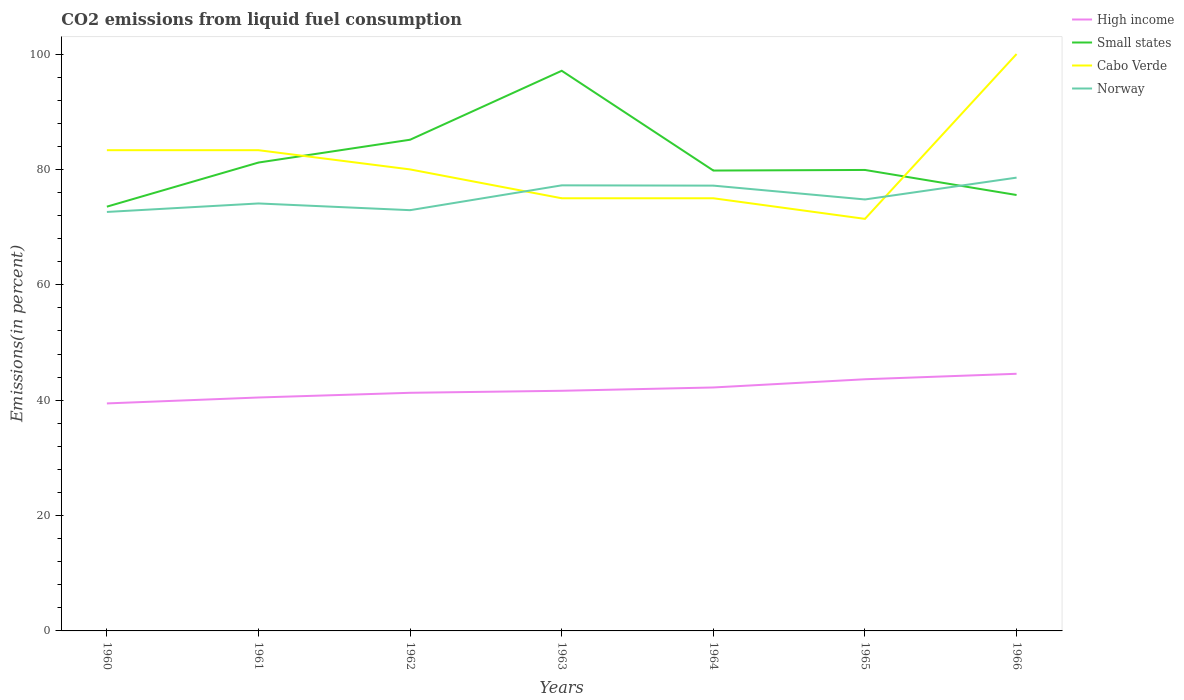How many different coloured lines are there?
Provide a short and direct response. 4. Does the line corresponding to Norway intersect with the line corresponding to Cabo Verde?
Give a very brief answer. Yes. Is the number of lines equal to the number of legend labels?
Provide a short and direct response. Yes. Across all years, what is the maximum total CO2 emitted in Small states?
Keep it short and to the point. 73.54. In which year was the total CO2 emitted in High income maximum?
Your answer should be compact. 1960. What is the total total CO2 emitted in Cabo Verde in the graph?
Make the answer very short. 8.33. What is the difference between the highest and the second highest total CO2 emitted in Cabo Verde?
Give a very brief answer. 28.57. Is the total CO2 emitted in High income strictly greater than the total CO2 emitted in Small states over the years?
Your response must be concise. Yes. How many years are there in the graph?
Keep it short and to the point. 7. What is the difference between two consecutive major ticks on the Y-axis?
Your response must be concise. 20. Does the graph contain any zero values?
Provide a short and direct response. No. Where does the legend appear in the graph?
Offer a terse response. Top right. How many legend labels are there?
Ensure brevity in your answer.  4. What is the title of the graph?
Offer a very short reply. CO2 emissions from liquid fuel consumption. Does "Honduras" appear as one of the legend labels in the graph?
Your response must be concise. No. What is the label or title of the X-axis?
Offer a terse response. Years. What is the label or title of the Y-axis?
Offer a very short reply. Emissions(in percent). What is the Emissions(in percent) of High income in 1960?
Your answer should be compact. 39.44. What is the Emissions(in percent) in Small states in 1960?
Give a very brief answer. 73.54. What is the Emissions(in percent) in Cabo Verde in 1960?
Give a very brief answer. 83.33. What is the Emissions(in percent) in Norway in 1960?
Your answer should be very brief. 72.63. What is the Emissions(in percent) of High income in 1961?
Provide a succinct answer. 40.46. What is the Emissions(in percent) in Small states in 1961?
Ensure brevity in your answer.  81.19. What is the Emissions(in percent) of Cabo Verde in 1961?
Provide a short and direct response. 83.33. What is the Emissions(in percent) in Norway in 1961?
Your answer should be compact. 74.1. What is the Emissions(in percent) of High income in 1962?
Offer a terse response. 41.28. What is the Emissions(in percent) of Small states in 1962?
Keep it short and to the point. 85.15. What is the Emissions(in percent) in Norway in 1962?
Provide a short and direct response. 72.94. What is the Emissions(in percent) of High income in 1963?
Ensure brevity in your answer.  41.63. What is the Emissions(in percent) in Small states in 1963?
Provide a succinct answer. 97.1. What is the Emissions(in percent) in Cabo Verde in 1963?
Your answer should be compact. 75. What is the Emissions(in percent) of Norway in 1963?
Your answer should be compact. 77.24. What is the Emissions(in percent) of High income in 1964?
Offer a very short reply. 42.2. What is the Emissions(in percent) in Small states in 1964?
Your response must be concise. 79.81. What is the Emissions(in percent) in Norway in 1964?
Ensure brevity in your answer.  77.19. What is the Emissions(in percent) in High income in 1965?
Provide a short and direct response. 43.63. What is the Emissions(in percent) of Small states in 1965?
Ensure brevity in your answer.  79.91. What is the Emissions(in percent) in Cabo Verde in 1965?
Ensure brevity in your answer.  71.43. What is the Emissions(in percent) in Norway in 1965?
Give a very brief answer. 74.79. What is the Emissions(in percent) in High income in 1966?
Your answer should be very brief. 44.57. What is the Emissions(in percent) of Small states in 1966?
Give a very brief answer. 75.56. What is the Emissions(in percent) of Cabo Verde in 1966?
Your response must be concise. 100. What is the Emissions(in percent) in Norway in 1966?
Ensure brevity in your answer.  78.58. Across all years, what is the maximum Emissions(in percent) of High income?
Make the answer very short. 44.57. Across all years, what is the maximum Emissions(in percent) in Small states?
Offer a terse response. 97.1. Across all years, what is the maximum Emissions(in percent) in Cabo Verde?
Keep it short and to the point. 100. Across all years, what is the maximum Emissions(in percent) in Norway?
Keep it short and to the point. 78.58. Across all years, what is the minimum Emissions(in percent) in High income?
Provide a short and direct response. 39.44. Across all years, what is the minimum Emissions(in percent) in Small states?
Offer a terse response. 73.54. Across all years, what is the minimum Emissions(in percent) of Cabo Verde?
Keep it short and to the point. 71.43. Across all years, what is the minimum Emissions(in percent) in Norway?
Provide a succinct answer. 72.63. What is the total Emissions(in percent) in High income in the graph?
Make the answer very short. 293.21. What is the total Emissions(in percent) of Small states in the graph?
Offer a terse response. 572.26. What is the total Emissions(in percent) of Cabo Verde in the graph?
Give a very brief answer. 568.1. What is the total Emissions(in percent) of Norway in the graph?
Ensure brevity in your answer.  527.46. What is the difference between the Emissions(in percent) in High income in 1960 and that in 1961?
Keep it short and to the point. -1.03. What is the difference between the Emissions(in percent) of Small states in 1960 and that in 1961?
Keep it short and to the point. -7.65. What is the difference between the Emissions(in percent) in Cabo Verde in 1960 and that in 1961?
Offer a very short reply. 0. What is the difference between the Emissions(in percent) of Norway in 1960 and that in 1961?
Keep it short and to the point. -1.47. What is the difference between the Emissions(in percent) of High income in 1960 and that in 1962?
Offer a terse response. -1.84. What is the difference between the Emissions(in percent) in Small states in 1960 and that in 1962?
Offer a terse response. -11.6. What is the difference between the Emissions(in percent) in Norway in 1960 and that in 1962?
Ensure brevity in your answer.  -0.31. What is the difference between the Emissions(in percent) of High income in 1960 and that in 1963?
Provide a short and direct response. -2.19. What is the difference between the Emissions(in percent) in Small states in 1960 and that in 1963?
Make the answer very short. -23.56. What is the difference between the Emissions(in percent) in Cabo Verde in 1960 and that in 1963?
Your answer should be very brief. 8.33. What is the difference between the Emissions(in percent) of Norway in 1960 and that in 1963?
Your response must be concise. -4.61. What is the difference between the Emissions(in percent) in High income in 1960 and that in 1964?
Give a very brief answer. -2.77. What is the difference between the Emissions(in percent) in Small states in 1960 and that in 1964?
Provide a short and direct response. -6.26. What is the difference between the Emissions(in percent) in Cabo Verde in 1960 and that in 1964?
Your response must be concise. 8.33. What is the difference between the Emissions(in percent) in Norway in 1960 and that in 1964?
Offer a very short reply. -4.56. What is the difference between the Emissions(in percent) in High income in 1960 and that in 1965?
Provide a short and direct response. -4.19. What is the difference between the Emissions(in percent) of Small states in 1960 and that in 1965?
Keep it short and to the point. -6.36. What is the difference between the Emissions(in percent) in Cabo Verde in 1960 and that in 1965?
Give a very brief answer. 11.9. What is the difference between the Emissions(in percent) in Norway in 1960 and that in 1965?
Offer a very short reply. -2.17. What is the difference between the Emissions(in percent) of High income in 1960 and that in 1966?
Keep it short and to the point. -5.14. What is the difference between the Emissions(in percent) in Small states in 1960 and that in 1966?
Offer a very short reply. -2.02. What is the difference between the Emissions(in percent) in Cabo Verde in 1960 and that in 1966?
Ensure brevity in your answer.  -16.67. What is the difference between the Emissions(in percent) in Norway in 1960 and that in 1966?
Your response must be concise. -5.95. What is the difference between the Emissions(in percent) in High income in 1961 and that in 1962?
Make the answer very short. -0.81. What is the difference between the Emissions(in percent) in Small states in 1961 and that in 1962?
Give a very brief answer. -3.96. What is the difference between the Emissions(in percent) of Cabo Verde in 1961 and that in 1962?
Offer a terse response. 3.33. What is the difference between the Emissions(in percent) of Norway in 1961 and that in 1962?
Give a very brief answer. 1.16. What is the difference between the Emissions(in percent) of High income in 1961 and that in 1963?
Provide a short and direct response. -1.16. What is the difference between the Emissions(in percent) of Small states in 1961 and that in 1963?
Keep it short and to the point. -15.91. What is the difference between the Emissions(in percent) of Cabo Verde in 1961 and that in 1963?
Your answer should be compact. 8.33. What is the difference between the Emissions(in percent) of Norway in 1961 and that in 1963?
Your answer should be very brief. -3.14. What is the difference between the Emissions(in percent) of High income in 1961 and that in 1964?
Provide a succinct answer. -1.74. What is the difference between the Emissions(in percent) in Small states in 1961 and that in 1964?
Offer a terse response. 1.39. What is the difference between the Emissions(in percent) in Cabo Verde in 1961 and that in 1964?
Offer a terse response. 8.33. What is the difference between the Emissions(in percent) of Norway in 1961 and that in 1964?
Give a very brief answer. -3.09. What is the difference between the Emissions(in percent) in High income in 1961 and that in 1965?
Ensure brevity in your answer.  -3.16. What is the difference between the Emissions(in percent) in Small states in 1961 and that in 1965?
Give a very brief answer. 1.29. What is the difference between the Emissions(in percent) in Cabo Verde in 1961 and that in 1965?
Your answer should be very brief. 11.9. What is the difference between the Emissions(in percent) in Norway in 1961 and that in 1965?
Your answer should be very brief. -0.69. What is the difference between the Emissions(in percent) of High income in 1961 and that in 1966?
Offer a terse response. -4.11. What is the difference between the Emissions(in percent) in Small states in 1961 and that in 1966?
Give a very brief answer. 5.63. What is the difference between the Emissions(in percent) of Cabo Verde in 1961 and that in 1966?
Offer a terse response. -16.67. What is the difference between the Emissions(in percent) in Norway in 1961 and that in 1966?
Offer a terse response. -4.47. What is the difference between the Emissions(in percent) of High income in 1962 and that in 1963?
Provide a short and direct response. -0.35. What is the difference between the Emissions(in percent) of Small states in 1962 and that in 1963?
Offer a very short reply. -11.95. What is the difference between the Emissions(in percent) of Norway in 1962 and that in 1963?
Provide a succinct answer. -4.3. What is the difference between the Emissions(in percent) of High income in 1962 and that in 1964?
Keep it short and to the point. -0.92. What is the difference between the Emissions(in percent) in Small states in 1962 and that in 1964?
Your answer should be compact. 5.34. What is the difference between the Emissions(in percent) in Cabo Verde in 1962 and that in 1964?
Make the answer very short. 5. What is the difference between the Emissions(in percent) of Norway in 1962 and that in 1964?
Provide a succinct answer. -4.26. What is the difference between the Emissions(in percent) of High income in 1962 and that in 1965?
Provide a succinct answer. -2.35. What is the difference between the Emissions(in percent) in Small states in 1962 and that in 1965?
Offer a terse response. 5.24. What is the difference between the Emissions(in percent) in Cabo Verde in 1962 and that in 1965?
Offer a very short reply. 8.57. What is the difference between the Emissions(in percent) in Norway in 1962 and that in 1965?
Your answer should be compact. -1.86. What is the difference between the Emissions(in percent) of High income in 1962 and that in 1966?
Ensure brevity in your answer.  -3.3. What is the difference between the Emissions(in percent) of Small states in 1962 and that in 1966?
Provide a succinct answer. 9.58. What is the difference between the Emissions(in percent) in Cabo Verde in 1962 and that in 1966?
Your answer should be compact. -20. What is the difference between the Emissions(in percent) in Norway in 1962 and that in 1966?
Keep it short and to the point. -5.64. What is the difference between the Emissions(in percent) in High income in 1963 and that in 1964?
Keep it short and to the point. -0.57. What is the difference between the Emissions(in percent) of Small states in 1963 and that in 1964?
Provide a short and direct response. 17.29. What is the difference between the Emissions(in percent) in Norway in 1963 and that in 1964?
Offer a terse response. 0.05. What is the difference between the Emissions(in percent) of High income in 1963 and that in 1965?
Offer a terse response. -2. What is the difference between the Emissions(in percent) of Small states in 1963 and that in 1965?
Ensure brevity in your answer.  17.19. What is the difference between the Emissions(in percent) of Cabo Verde in 1963 and that in 1965?
Your response must be concise. 3.57. What is the difference between the Emissions(in percent) of Norway in 1963 and that in 1965?
Provide a short and direct response. 2.45. What is the difference between the Emissions(in percent) in High income in 1963 and that in 1966?
Give a very brief answer. -2.95. What is the difference between the Emissions(in percent) in Small states in 1963 and that in 1966?
Make the answer very short. 21.53. What is the difference between the Emissions(in percent) in Norway in 1963 and that in 1966?
Offer a very short reply. -1.34. What is the difference between the Emissions(in percent) in High income in 1964 and that in 1965?
Offer a terse response. -1.42. What is the difference between the Emissions(in percent) in Small states in 1964 and that in 1965?
Offer a very short reply. -0.1. What is the difference between the Emissions(in percent) in Cabo Verde in 1964 and that in 1965?
Provide a succinct answer. 3.57. What is the difference between the Emissions(in percent) in Norway in 1964 and that in 1965?
Keep it short and to the point. 2.4. What is the difference between the Emissions(in percent) in High income in 1964 and that in 1966?
Make the answer very short. -2.37. What is the difference between the Emissions(in percent) of Small states in 1964 and that in 1966?
Give a very brief answer. 4.24. What is the difference between the Emissions(in percent) in Norway in 1964 and that in 1966?
Keep it short and to the point. -1.38. What is the difference between the Emissions(in percent) of High income in 1965 and that in 1966?
Your answer should be compact. -0.95. What is the difference between the Emissions(in percent) in Small states in 1965 and that in 1966?
Offer a terse response. 4.34. What is the difference between the Emissions(in percent) in Cabo Verde in 1965 and that in 1966?
Make the answer very short. -28.57. What is the difference between the Emissions(in percent) of Norway in 1965 and that in 1966?
Provide a short and direct response. -3.78. What is the difference between the Emissions(in percent) of High income in 1960 and the Emissions(in percent) of Small states in 1961?
Provide a short and direct response. -41.76. What is the difference between the Emissions(in percent) of High income in 1960 and the Emissions(in percent) of Cabo Verde in 1961?
Your response must be concise. -43.9. What is the difference between the Emissions(in percent) of High income in 1960 and the Emissions(in percent) of Norway in 1961?
Offer a very short reply. -34.66. What is the difference between the Emissions(in percent) of Small states in 1960 and the Emissions(in percent) of Cabo Verde in 1961?
Your answer should be very brief. -9.79. What is the difference between the Emissions(in percent) in Small states in 1960 and the Emissions(in percent) in Norway in 1961?
Your answer should be compact. -0.56. What is the difference between the Emissions(in percent) of Cabo Verde in 1960 and the Emissions(in percent) of Norway in 1961?
Your answer should be compact. 9.23. What is the difference between the Emissions(in percent) of High income in 1960 and the Emissions(in percent) of Small states in 1962?
Your response must be concise. -45.71. What is the difference between the Emissions(in percent) in High income in 1960 and the Emissions(in percent) in Cabo Verde in 1962?
Offer a very short reply. -40.56. What is the difference between the Emissions(in percent) of High income in 1960 and the Emissions(in percent) of Norway in 1962?
Provide a short and direct response. -33.5. What is the difference between the Emissions(in percent) of Small states in 1960 and the Emissions(in percent) of Cabo Verde in 1962?
Offer a very short reply. -6.46. What is the difference between the Emissions(in percent) in Small states in 1960 and the Emissions(in percent) in Norway in 1962?
Offer a very short reply. 0.61. What is the difference between the Emissions(in percent) in Cabo Verde in 1960 and the Emissions(in percent) in Norway in 1962?
Keep it short and to the point. 10.4. What is the difference between the Emissions(in percent) in High income in 1960 and the Emissions(in percent) in Small states in 1963?
Your answer should be compact. -57.66. What is the difference between the Emissions(in percent) of High income in 1960 and the Emissions(in percent) of Cabo Verde in 1963?
Provide a succinct answer. -35.56. What is the difference between the Emissions(in percent) in High income in 1960 and the Emissions(in percent) in Norway in 1963?
Provide a short and direct response. -37.8. What is the difference between the Emissions(in percent) in Small states in 1960 and the Emissions(in percent) in Cabo Verde in 1963?
Ensure brevity in your answer.  -1.46. What is the difference between the Emissions(in percent) in Small states in 1960 and the Emissions(in percent) in Norway in 1963?
Give a very brief answer. -3.7. What is the difference between the Emissions(in percent) of Cabo Verde in 1960 and the Emissions(in percent) of Norway in 1963?
Make the answer very short. 6.09. What is the difference between the Emissions(in percent) in High income in 1960 and the Emissions(in percent) in Small states in 1964?
Offer a terse response. -40.37. What is the difference between the Emissions(in percent) of High income in 1960 and the Emissions(in percent) of Cabo Verde in 1964?
Provide a short and direct response. -35.56. What is the difference between the Emissions(in percent) of High income in 1960 and the Emissions(in percent) of Norway in 1964?
Offer a very short reply. -37.76. What is the difference between the Emissions(in percent) in Small states in 1960 and the Emissions(in percent) in Cabo Verde in 1964?
Offer a very short reply. -1.46. What is the difference between the Emissions(in percent) in Small states in 1960 and the Emissions(in percent) in Norway in 1964?
Provide a succinct answer. -3.65. What is the difference between the Emissions(in percent) in Cabo Verde in 1960 and the Emissions(in percent) in Norway in 1964?
Make the answer very short. 6.14. What is the difference between the Emissions(in percent) in High income in 1960 and the Emissions(in percent) in Small states in 1965?
Give a very brief answer. -40.47. What is the difference between the Emissions(in percent) in High income in 1960 and the Emissions(in percent) in Cabo Verde in 1965?
Offer a very short reply. -31.99. What is the difference between the Emissions(in percent) in High income in 1960 and the Emissions(in percent) in Norway in 1965?
Provide a short and direct response. -35.36. What is the difference between the Emissions(in percent) of Small states in 1960 and the Emissions(in percent) of Cabo Verde in 1965?
Make the answer very short. 2.12. What is the difference between the Emissions(in percent) in Small states in 1960 and the Emissions(in percent) in Norway in 1965?
Offer a very short reply. -1.25. What is the difference between the Emissions(in percent) in Cabo Verde in 1960 and the Emissions(in percent) in Norway in 1965?
Give a very brief answer. 8.54. What is the difference between the Emissions(in percent) of High income in 1960 and the Emissions(in percent) of Small states in 1966?
Give a very brief answer. -36.13. What is the difference between the Emissions(in percent) in High income in 1960 and the Emissions(in percent) in Cabo Verde in 1966?
Provide a short and direct response. -60.56. What is the difference between the Emissions(in percent) of High income in 1960 and the Emissions(in percent) of Norway in 1966?
Your answer should be compact. -39.14. What is the difference between the Emissions(in percent) in Small states in 1960 and the Emissions(in percent) in Cabo Verde in 1966?
Offer a terse response. -26.46. What is the difference between the Emissions(in percent) of Small states in 1960 and the Emissions(in percent) of Norway in 1966?
Offer a very short reply. -5.03. What is the difference between the Emissions(in percent) in Cabo Verde in 1960 and the Emissions(in percent) in Norway in 1966?
Your response must be concise. 4.76. What is the difference between the Emissions(in percent) of High income in 1961 and the Emissions(in percent) of Small states in 1962?
Provide a succinct answer. -44.68. What is the difference between the Emissions(in percent) of High income in 1961 and the Emissions(in percent) of Cabo Verde in 1962?
Give a very brief answer. -39.54. What is the difference between the Emissions(in percent) of High income in 1961 and the Emissions(in percent) of Norway in 1962?
Offer a terse response. -32.47. What is the difference between the Emissions(in percent) in Small states in 1961 and the Emissions(in percent) in Cabo Verde in 1962?
Your answer should be compact. 1.19. What is the difference between the Emissions(in percent) of Small states in 1961 and the Emissions(in percent) of Norway in 1962?
Offer a very short reply. 8.26. What is the difference between the Emissions(in percent) of Cabo Verde in 1961 and the Emissions(in percent) of Norway in 1962?
Offer a terse response. 10.4. What is the difference between the Emissions(in percent) of High income in 1961 and the Emissions(in percent) of Small states in 1963?
Keep it short and to the point. -56.64. What is the difference between the Emissions(in percent) in High income in 1961 and the Emissions(in percent) in Cabo Verde in 1963?
Provide a short and direct response. -34.54. What is the difference between the Emissions(in percent) in High income in 1961 and the Emissions(in percent) in Norway in 1963?
Ensure brevity in your answer.  -36.78. What is the difference between the Emissions(in percent) of Small states in 1961 and the Emissions(in percent) of Cabo Verde in 1963?
Provide a short and direct response. 6.19. What is the difference between the Emissions(in percent) in Small states in 1961 and the Emissions(in percent) in Norway in 1963?
Make the answer very short. 3.95. What is the difference between the Emissions(in percent) in Cabo Verde in 1961 and the Emissions(in percent) in Norway in 1963?
Provide a succinct answer. 6.09. What is the difference between the Emissions(in percent) of High income in 1961 and the Emissions(in percent) of Small states in 1964?
Provide a short and direct response. -39.34. What is the difference between the Emissions(in percent) of High income in 1961 and the Emissions(in percent) of Cabo Verde in 1964?
Make the answer very short. -34.54. What is the difference between the Emissions(in percent) of High income in 1961 and the Emissions(in percent) of Norway in 1964?
Your answer should be compact. -36.73. What is the difference between the Emissions(in percent) in Small states in 1961 and the Emissions(in percent) in Cabo Verde in 1964?
Make the answer very short. 6.19. What is the difference between the Emissions(in percent) in Small states in 1961 and the Emissions(in percent) in Norway in 1964?
Offer a terse response. 4. What is the difference between the Emissions(in percent) of Cabo Verde in 1961 and the Emissions(in percent) of Norway in 1964?
Offer a very short reply. 6.14. What is the difference between the Emissions(in percent) of High income in 1961 and the Emissions(in percent) of Small states in 1965?
Offer a terse response. -39.44. What is the difference between the Emissions(in percent) of High income in 1961 and the Emissions(in percent) of Cabo Verde in 1965?
Provide a short and direct response. -30.96. What is the difference between the Emissions(in percent) of High income in 1961 and the Emissions(in percent) of Norway in 1965?
Your answer should be very brief. -34.33. What is the difference between the Emissions(in percent) in Small states in 1961 and the Emissions(in percent) in Cabo Verde in 1965?
Offer a very short reply. 9.76. What is the difference between the Emissions(in percent) in Small states in 1961 and the Emissions(in percent) in Norway in 1965?
Your answer should be compact. 6.4. What is the difference between the Emissions(in percent) in Cabo Verde in 1961 and the Emissions(in percent) in Norway in 1965?
Your response must be concise. 8.54. What is the difference between the Emissions(in percent) of High income in 1961 and the Emissions(in percent) of Small states in 1966?
Give a very brief answer. -35.1. What is the difference between the Emissions(in percent) of High income in 1961 and the Emissions(in percent) of Cabo Verde in 1966?
Keep it short and to the point. -59.54. What is the difference between the Emissions(in percent) in High income in 1961 and the Emissions(in percent) in Norway in 1966?
Provide a short and direct response. -38.11. What is the difference between the Emissions(in percent) in Small states in 1961 and the Emissions(in percent) in Cabo Verde in 1966?
Your response must be concise. -18.81. What is the difference between the Emissions(in percent) in Small states in 1961 and the Emissions(in percent) in Norway in 1966?
Ensure brevity in your answer.  2.62. What is the difference between the Emissions(in percent) in Cabo Verde in 1961 and the Emissions(in percent) in Norway in 1966?
Your answer should be compact. 4.76. What is the difference between the Emissions(in percent) of High income in 1962 and the Emissions(in percent) of Small states in 1963?
Ensure brevity in your answer.  -55.82. What is the difference between the Emissions(in percent) in High income in 1962 and the Emissions(in percent) in Cabo Verde in 1963?
Your answer should be very brief. -33.72. What is the difference between the Emissions(in percent) in High income in 1962 and the Emissions(in percent) in Norway in 1963?
Your answer should be very brief. -35.96. What is the difference between the Emissions(in percent) of Small states in 1962 and the Emissions(in percent) of Cabo Verde in 1963?
Keep it short and to the point. 10.15. What is the difference between the Emissions(in percent) in Small states in 1962 and the Emissions(in percent) in Norway in 1963?
Provide a short and direct response. 7.91. What is the difference between the Emissions(in percent) of Cabo Verde in 1962 and the Emissions(in percent) of Norway in 1963?
Give a very brief answer. 2.76. What is the difference between the Emissions(in percent) of High income in 1962 and the Emissions(in percent) of Small states in 1964?
Your response must be concise. -38.53. What is the difference between the Emissions(in percent) in High income in 1962 and the Emissions(in percent) in Cabo Verde in 1964?
Offer a terse response. -33.72. What is the difference between the Emissions(in percent) in High income in 1962 and the Emissions(in percent) in Norway in 1964?
Keep it short and to the point. -35.91. What is the difference between the Emissions(in percent) in Small states in 1962 and the Emissions(in percent) in Cabo Verde in 1964?
Your response must be concise. 10.15. What is the difference between the Emissions(in percent) in Small states in 1962 and the Emissions(in percent) in Norway in 1964?
Your answer should be compact. 7.96. What is the difference between the Emissions(in percent) of Cabo Verde in 1962 and the Emissions(in percent) of Norway in 1964?
Ensure brevity in your answer.  2.81. What is the difference between the Emissions(in percent) of High income in 1962 and the Emissions(in percent) of Small states in 1965?
Offer a very short reply. -38.63. What is the difference between the Emissions(in percent) of High income in 1962 and the Emissions(in percent) of Cabo Verde in 1965?
Give a very brief answer. -30.15. What is the difference between the Emissions(in percent) in High income in 1962 and the Emissions(in percent) in Norway in 1965?
Your response must be concise. -33.51. What is the difference between the Emissions(in percent) in Small states in 1962 and the Emissions(in percent) in Cabo Verde in 1965?
Make the answer very short. 13.72. What is the difference between the Emissions(in percent) of Small states in 1962 and the Emissions(in percent) of Norway in 1965?
Ensure brevity in your answer.  10.35. What is the difference between the Emissions(in percent) in Cabo Verde in 1962 and the Emissions(in percent) in Norway in 1965?
Keep it short and to the point. 5.21. What is the difference between the Emissions(in percent) of High income in 1962 and the Emissions(in percent) of Small states in 1966?
Your response must be concise. -34.29. What is the difference between the Emissions(in percent) in High income in 1962 and the Emissions(in percent) in Cabo Verde in 1966?
Give a very brief answer. -58.72. What is the difference between the Emissions(in percent) in High income in 1962 and the Emissions(in percent) in Norway in 1966?
Give a very brief answer. -37.3. What is the difference between the Emissions(in percent) of Small states in 1962 and the Emissions(in percent) of Cabo Verde in 1966?
Your answer should be very brief. -14.85. What is the difference between the Emissions(in percent) in Small states in 1962 and the Emissions(in percent) in Norway in 1966?
Give a very brief answer. 6.57. What is the difference between the Emissions(in percent) of Cabo Verde in 1962 and the Emissions(in percent) of Norway in 1966?
Keep it short and to the point. 1.42. What is the difference between the Emissions(in percent) of High income in 1963 and the Emissions(in percent) of Small states in 1964?
Provide a succinct answer. -38.18. What is the difference between the Emissions(in percent) of High income in 1963 and the Emissions(in percent) of Cabo Verde in 1964?
Keep it short and to the point. -33.37. What is the difference between the Emissions(in percent) in High income in 1963 and the Emissions(in percent) in Norway in 1964?
Ensure brevity in your answer.  -35.56. What is the difference between the Emissions(in percent) of Small states in 1963 and the Emissions(in percent) of Cabo Verde in 1964?
Offer a terse response. 22.1. What is the difference between the Emissions(in percent) of Small states in 1963 and the Emissions(in percent) of Norway in 1964?
Ensure brevity in your answer.  19.91. What is the difference between the Emissions(in percent) of Cabo Verde in 1963 and the Emissions(in percent) of Norway in 1964?
Your answer should be very brief. -2.19. What is the difference between the Emissions(in percent) of High income in 1963 and the Emissions(in percent) of Small states in 1965?
Offer a very short reply. -38.28. What is the difference between the Emissions(in percent) of High income in 1963 and the Emissions(in percent) of Cabo Verde in 1965?
Give a very brief answer. -29.8. What is the difference between the Emissions(in percent) of High income in 1963 and the Emissions(in percent) of Norway in 1965?
Your response must be concise. -33.17. What is the difference between the Emissions(in percent) in Small states in 1963 and the Emissions(in percent) in Cabo Verde in 1965?
Offer a very short reply. 25.67. What is the difference between the Emissions(in percent) in Small states in 1963 and the Emissions(in percent) in Norway in 1965?
Offer a terse response. 22.31. What is the difference between the Emissions(in percent) of Cabo Verde in 1963 and the Emissions(in percent) of Norway in 1965?
Your answer should be very brief. 0.21. What is the difference between the Emissions(in percent) in High income in 1963 and the Emissions(in percent) in Small states in 1966?
Offer a terse response. -33.94. What is the difference between the Emissions(in percent) in High income in 1963 and the Emissions(in percent) in Cabo Verde in 1966?
Your answer should be very brief. -58.37. What is the difference between the Emissions(in percent) of High income in 1963 and the Emissions(in percent) of Norway in 1966?
Offer a very short reply. -36.95. What is the difference between the Emissions(in percent) of Small states in 1963 and the Emissions(in percent) of Cabo Verde in 1966?
Provide a succinct answer. -2.9. What is the difference between the Emissions(in percent) in Small states in 1963 and the Emissions(in percent) in Norway in 1966?
Offer a terse response. 18.52. What is the difference between the Emissions(in percent) of Cabo Verde in 1963 and the Emissions(in percent) of Norway in 1966?
Your response must be concise. -3.58. What is the difference between the Emissions(in percent) of High income in 1964 and the Emissions(in percent) of Small states in 1965?
Keep it short and to the point. -37.71. What is the difference between the Emissions(in percent) in High income in 1964 and the Emissions(in percent) in Cabo Verde in 1965?
Your response must be concise. -29.23. What is the difference between the Emissions(in percent) in High income in 1964 and the Emissions(in percent) in Norway in 1965?
Ensure brevity in your answer.  -32.59. What is the difference between the Emissions(in percent) of Small states in 1964 and the Emissions(in percent) of Cabo Verde in 1965?
Make the answer very short. 8.38. What is the difference between the Emissions(in percent) of Small states in 1964 and the Emissions(in percent) of Norway in 1965?
Give a very brief answer. 5.01. What is the difference between the Emissions(in percent) in Cabo Verde in 1964 and the Emissions(in percent) in Norway in 1965?
Give a very brief answer. 0.21. What is the difference between the Emissions(in percent) of High income in 1964 and the Emissions(in percent) of Small states in 1966?
Keep it short and to the point. -33.36. What is the difference between the Emissions(in percent) in High income in 1964 and the Emissions(in percent) in Cabo Verde in 1966?
Your answer should be very brief. -57.8. What is the difference between the Emissions(in percent) in High income in 1964 and the Emissions(in percent) in Norway in 1966?
Make the answer very short. -36.37. What is the difference between the Emissions(in percent) in Small states in 1964 and the Emissions(in percent) in Cabo Verde in 1966?
Make the answer very short. -20.19. What is the difference between the Emissions(in percent) in Small states in 1964 and the Emissions(in percent) in Norway in 1966?
Keep it short and to the point. 1.23. What is the difference between the Emissions(in percent) in Cabo Verde in 1964 and the Emissions(in percent) in Norway in 1966?
Provide a short and direct response. -3.58. What is the difference between the Emissions(in percent) in High income in 1965 and the Emissions(in percent) in Small states in 1966?
Your answer should be compact. -31.94. What is the difference between the Emissions(in percent) in High income in 1965 and the Emissions(in percent) in Cabo Verde in 1966?
Your answer should be compact. -56.37. What is the difference between the Emissions(in percent) of High income in 1965 and the Emissions(in percent) of Norway in 1966?
Provide a succinct answer. -34.95. What is the difference between the Emissions(in percent) of Small states in 1965 and the Emissions(in percent) of Cabo Verde in 1966?
Provide a succinct answer. -20.09. What is the difference between the Emissions(in percent) in Small states in 1965 and the Emissions(in percent) in Norway in 1966?
Your answer should be very brief. 1.33. What is the difference between the Emissions(in percent) in Cabo Verde in 1965 and the Emissions(in percent) in Norway in 1966?
Your answer should be compact. -7.15. What is the average Emissions(in percent) of High income per year?
Provide a short and direct response. 41.89. What is the average Emissions(in percent) of Small states per year?
Make the answer very short. 81.75. What is the average Emissions(in percent) in Cabo Verde per year?
Provide a succinct answer. 81.16. What is the average Emissions(in percent) of Norway per year?
Keep it short and to the point. 75.35. In the year 1960, what is the difference between the Emissions(in percent) of High income and Emissions(in percent) of Small states?
Ensure brevity in your answer.  -34.11. In the year 1960, what is the difference between the Emissions(in percent) in High income and Emissions(in percent) in Cabo Verde?
Your response must be concise. -43.9. In the year 1960, what is the difference between the Emissions(in percent) of High income and Emissions(in percent) of Norway?
Provide a succinct answer. -33.19. In the year 1960, what is the difference between the Emissions(in percent) of Small states and Emissions(in percent) of Cabo Verde?
Keep it short and to the point. -9.79. In the year 1960, what is the difference between the Emissions(in percent) of Small states and Emissions(in percent) of Norway?
Provide a short and direct response. 0.92. In the year 1960, what is the difference between the Emissions(in percent) in Cabo Verde and Emissions(in percent) in Norway?
Provide a short and direct response. 10.71. In the year 1961, what is the difference between the Emissions(in percent) in High income and Emissions(in percent) in Small states?
Provide a short and direct response. -40.73. In the year 1961, what is the difference between the Emissions(in percent) in High income and Emissions(in percent) in Cabo Verde?
Give a very brief answer. -42.87. In the year 1961, what is the difference between the Emissions(in percent) in High income and Emissions(in percent) in Norway?
Provide a short and direct response. -33.64. In the year 1961, what is the difference between the Emissions(in percent) of Small states and Emissions(in percent) of Cabo Verde?
Offer a terse response. -2.14. In the year 1961, what is the difference between the Emissions(in percent) in Small states and Emissions(in percent) in Norway?
Offer a very short reply. 7.09. In the year 1961, what is the difference between the Emissions(in percent) of Cabo Verde and Emissions(in percent) of Norway?
Your response must be concise. 9.23. In the year 1962, what is the difference between the Emissions(in percent) in High income and Emissions(in percent) in Small states?
Make the answer very short. -43.87. In the year 1962, what is the difference between the Emissions(in percent) in High income and Emissions(in percent) in Cabo Verde?
Your response must be concise. -38.72. In the year 1962, what is the difference between the Emissions(in percent) of High income and Emissions(in percent) of Norway?
Provide a succinct answer. -31.66. In the year 1962, what is the difference between the Emissions(in percent) of Small states and Emissions(in percent) of Cabo Verde?
Your response must be concise. 5.15. In the year 1962, what is the difference between the Emissions(in percent) of Small states and Emissions(in percent) of Norway?
Your answer should be compact. 12.21. In the year 1962, what is the difference between the Emissions(in percent) of Cabo Verde and Emissions(in percent) of Norway?
Provide a short and direct response. 7.06. In the year 1963, what is the difference between the Emissions(in percent) of High income and Emissions(in percent) of Small states?
Ensure brevity in your answer.  -55.47. In the year 1963, what is the difference between the Emissions(in percent) of High income and Emissions(in percent) of Cabo Verde?
Ensure brevity in your answer.  -33.37. In the year 1963, what is the difference between the Emissions(in percent) of High income and Emissions(in percent) of Norway?
Provide a short and direct response. -35.61. In the year 1963, what is the difference between the Emissions(in percent) in Small states and Emissions(in percent) in Cabo Verde?
Give a very brief answer. 22.1. In the year 1963, what is the difference between the Emissions(in percent) of Small states and Emissions(in percent) of Norway?
Ensure brevity in your answer.  19.86. In the year 1963, what is the difference between the Emissions(in percent) in Cabo Verde and Emissions(in percent) in Norway?
Offer a terse response. -2.24. In the year 1964, what is the difference between the Emissions(in percent) in High income and Emissions(in percent) in Small states?
Your answer should be compact. -37.6. In the year 1964, what is the difference between the Emissions(in percent) in High income and Emissions(in percent) in Cabo Verde?
Your answer should be compact. -32.8. In the year 1964, what is the difference between the Emissions(in percent) of High income and Emissions(in percent) of Norway?
Provide a short and direct response. -34.99. In the year 1964, what is the difference between the Emissions(in percent) of Small states and Emissions(in percent) of Cabo Verde?
Make the answer very short. 4.81. In the year 1964, what is the difference between the Emissions(in percent) in Small states and Emissions(in percent) in Norway?
Your answer should be very brief. 2.61. In the year 1964, what is the difference between the Emissions(in percent) in Cabo Verde and Emissions(in percent) in Norway?
Your answer should be very brief. -2.19. In the year 1965, what is the difference between the Emissions(in percent) of High income and Emissions(in percent) of Small states?
Provide a short and direct response. -36.28. In the year 1965, what is the difference between the Emissions(in percent) of High income and Emissions(in percent) of Cabo Verde?
Offer a very short reply. -27.8. In the year 1965, what is the difference between the Emissions(in percent) in High income and Emissions(in percent) in Norway?
Provide a succinct answer. -31.17. In the year 1965, what is the difference between the Emissions(in percent) in Small states and Emissions(in percent) in Cabo Verde?
Ensure brevity in your answer.  8.48. In the year 1965, what is the difference between the Emissions(in percent) of Small states and Emissions(in percent) of Norway?
Provide a succinct answer. 5.11. In the year 1965, what is the difference between the Emissions(in percent) of Cabo Verde and Emissions(in percent) of Norway?
Your answer should be compact. -3.36. In the year 1966, what is the difference between the Emissions(in percent) of High income and Emissions(in percent) of Small states?
Offer a very short reply. -30.99. In the year 1966, what is the difference between the Emissions(in percent) of High income and Emissions(in percent) of Cabo Verde?
Keep it short and to the point. -55.43. In the year 1966, what is the difference between the Emissions(in percent) in High income and Emissions(in percent) in Norway?
Offer a very short reply. -34. In the year 1966, what is the difference between the Emissions(in percent) of Small states and Emissions(in percent) of Cabo Verde?
Provide a short and direct response. -24.44. In the year 1966, what is the difference between the Emissions(in percent) in Small states and Emissions(in percent) in Norway?
Offer a terse response. -3.01. In the year 1966, what is the difference between the Emissions(in percent) in Cabo Verde and Emissions(in percent) in Norway?
Keep it short and to the point. 21.42. What is the ratio of the Emissions(in percent) of High income in 1960 to that in 1961?
Provide a succinct answer. 0.97. What is the ratio of the Emissions(in percent) of Small states in 1960 to that in 1961?
Make the answer very short. 0.91. What is the ratio of the Emissions(in percent) of Norway in 1960 to that in 1961?
Keep it short and to the point. 0.98. What is the ratio of the Emissions(in percent) of High income in 1960 to that in 1962?
Your answer should be compact. 0.96. What is the ratio of the Emissions(in percent) in Small states in 1960 to that in 1962?
Your answer should be compact. 0.86. What is the ratio of the Emissions(in percent) of Cabo Verde in 1960 to that in 1962?
Make the answer very short. 1.04. What is the ratio of the Emissions(in percent) in High income in 1960 to that in 1963?
Provide a succinct answer. 0.95. What is the ratio of the Emissions(in percent) in Small states in 1960 to that in 1963?
Your response must be concise. 0.76. What is the ratio of the Emissions(in percent) of Cabo Verde in 1960 to that in 1963?
Ensure brevity in your answer.  1.11. What is the ratio of the Emissions(in percent) in Norway in 1960 to that in 1963?
Your answer should be compact. 0.94. What is the ratio of the Emissions(in percent) of High income in 1960 to that in 1964?
Give a very brief answer. 0.93. What is the ratio of the Emissions(in percent) of Small states in 1960 to that in 1964?
Your response must be concise. 0.92. What is the ratio of the Emissions(in percent) of Norway in 1960 to that in 1964?
Make the answer very short. 0.94. What is the ratio of the Emissions(in percent) in High income in 1960 to that in 1965?
Provide a short and direct response. 0.9. What is the ratio of the Emissions(in percent) of Small states in 1960 to that in 1965?
Keep it short and to the point. 0.92. What is the ratio of the Emissions(in percent) of Norway in 1960 to that in 1965?
Your response must be concise. 0.97. What is the ratio of the Emissions(in percent) in High income in 1960 to that in 1966?
Provide a succinct answer. 0.88. What is the ratio of the Emissions(in percent) of Small states in 1960 to that in 1966?
Make the answer very short. 0.97. What is the ratio of the Emissions(in percent) in Norway in 1960 to that in 1966?
Offer a very short reply. 0.92. What is the ratio of the Emissions(in percent) of High income in 1961 to that in 1962?
Ensure brevity in your answer.  0.98. What is the ratio of the Emissions(in percent) of Small states in 1961 to that in 1962?
Your answer should be very brief. 0.95. What is the ratio of the Emissions(in percent) in Cabo Verde in 1961 to that in 1962?
Your answer should be compact. 1.04. What is the ratio of the Emissions(in percent) in Small states in 1961 to that in 1963?
Offer a terse response. 0.84. What is the ratio of the Emissions(in percent) of Norway in 1961 to that in 1963?
Keep it short and to the point. 0.96. What is the ratio of the Emissions(in percent) in High income in 1961 to that in 1964?
Ensure brevity in your answer.  0.96. What is the ratio of the Emissions(in percent) of Small states in 1961 to that in 1964?
Ensure brevity in your answer.  1.02. What is the ratio of the Emissions(in percent) in Cabo Verde in 1961 to that in 1964?
Your answer should be compact. 1.11. What is the ratio of the Emissions(in percent) of High income in 1961 to that in 1965?
Provide a short and direct response. 0.93. What is the ratio of the Emissions(in percent) in Small states in 1961 to that in 1965?
Your answer should be very brief. 1.02. What is the ratio of the Emissions(in percent) of Norway in 1961 to that in 1965?
Give a very brief answer. 0.99. What is the ratio of the Emissions(in percent) in High income in 1961 to that in 1966?
Your answer should be very brief. 0.91. What is the ratio of the Emissions(in percent) in Small states in 1961 to that in 1966?
Provide a succinct answer. 1.07. What is the ratio of the Emissions(in percent) of Cabo Verde in 1961 to that in 1966?
Ensure brevity in your answer.  0.83. What is the ratio of the Emissions(in percent) in Norway in 1961 to that in 1966?
Provide a short and direct response. 0.94. What is the ratio of the Emissions(in percent) in High income in 1962 to that in 1963?
Your answer should be very brief. 0.99. What is the ratio of the Emissions(in percent) in Small states in 1962 to that in 1963?
Make the answer very short. 0.88. What is the ratio of the Emissions(in percent) in Cabo Verde in 1962 to that in 1963?
Provide a succinct answer. 1.07. What is the ratio of the Emissions(in percent) in Norway in 1962 to that in 1963?
Your response must be concise. 0.94. What is the ratio of the Emissions(in percent) in High income in 1962 to that in 1964?
Your answer should be compact. 0.98. What is the ratio of the Emissions(in percent) of Small states in 1962 to that in 1964?
Give a very brief answer. 1.07. What is the ratio of the Emissions(in percent) in Cabo Verde in 1962 to that in 1964?
Make the answer very short. 1.07. What is the ratio of the Emissions(in percent) of Norway in 1962 to that in 1964?
Your answer should be very brief. 0.94. What is the ratio of the Emissions(in percent) in High income in 1962 to that in 1965?
Provide a short and direct response. 0.95. What is the ratio of the Emissions(in percent) of Small states in 1962 to that in 1965?
Your response must be concise. 1.07. What is the ratio of the Emissions(in percent) of Cabo Verde in 1962 to that in 1965?
Offer a very short reply. 1.12. What is the ratio of the Emissions(in percent) of Norway in 1962 to that in 1965?
Your answer should be very brief. 0.98. What is the ratio of the Emissions(in percent) in High income in 1962 to that in 1966?
Provide a short and direct response. 0.93. What is the ratio of the Emissions(in percent) of Small states in 1962 to that in 1966?
Your answer should be very brief. 1.13. What is the ratio of the Emissions(in percent) of Cabo Verde in 1962 to that in 1966?
Offer a terse response. 0.8. What is the ratio of the Emissions(in percent) in Norway in 1962 to that in 1966?
Make the answer very short. 0.93. What is the ratio of the Emissions(in percent) of High income in 1963 to that in 1964?
Keep it short and to the point. 0.99. What is the ratio of the Emissions(in percent) in Small states in 1963 to that in 1964?
Your response must be concise. 1.22. What is the ratio of the Emissions(in percent) in Cabo Verde in 1963 to that in 1964?
Ensure brevity in your answer.  1. What is the ratio of the Emissions(in percent) of High income in 1963 to that in 1965?
Provide a succinct answer. 0.95. What is the ratio of the Emissions(in percent) in Small states in 1963 to that in 1965?
Provide a succinct answer. 1.22. What is the ratio of the Emissions(in percent) in Norway in 1963 to that in 1965?
Offer a terse response. 1.03. What is the ratio of the Emissions(in percent) of High income in 1963 to that in 1966?
Make the answer very short. 0.93. What is the ratio of the Emissions(in percent) of Small states in 1963 to that in 1966?
Give a very brief answer. 1.28. What is the ratio of the Emissions(in percent) in Cabo Verde in 1963 to that in 1966?
Give a very brief answer. 0.75. What is the ratio of the Emissions(in percent) of Norway in 1963 to that in 1966?
Keep it short and to the point. 0.98. What is the ratio of the Emissions(in percent) of High income in 1964 to that in 1965?
Offer a very short reply. 0.97. What is the ratio of the Emissions(in percent) in Small states in 1964 to that in 1965?
Offer a very short reply. 1. What is the ratio of the Emissions(in percent) of Cabo Verde in 1964 to that in 1965?
Ensure brevity in your answer.  1.05. What is the ratio of the Emissions(in percent) in Norway in 1964 to that in 1965?
Your answer should be compact. 1.03. What is the ratio of the Emissions(in percent) in High income in 1964 to that in 1966?
Offer a terse response. 0.95. What is the ratio of the Emissions(in percent) in Small states in 1964 to that in 1966?
Offer a terse response. 1.06. What is the ratio of the Emissions(in percent) of Cabo Verde in 1964 to that in 1966?
Give a very brief answer. 0.75. What is the ratio of the Emissions(in percent) of Norway in 1964 to that in 1966?
Make the answer very short. 0.98. What is the ratio of the Emissions(in percent) in High income in 1965 to that in 1966?
Give a very brief answer. 0.98. What is the ratio of the Emissions(in percent) of Small states in 1965 to that in 1966?
Give a very brief answer. 1.06. What is the ratio of the Emissions(in percent) of Cabo Verde in 1965 to that in 1966?
Ensure brevity in your answer.  0.71. What is the ratio of the Emissions(in percent) in Norway in 1965 to that in 1966?
Keep it short and to the point. 0.95. What is the difference between the highest and the second highest Emissions(in percent) in High income?
Your response must be concise. 0.95. What is the difference between the highest and the second highest Emissions(in percent) of Small states?
Ensure brevity in your answer.  11.95. What is the difference between the highest and the second highest Emissions(in percent) of Cabo Verde?
Give a very brief answer. 16.67. What is the difference between the highest and the second highest Emissions(in percent) of Norway?
Your answer should be very brief. 1.34. What is the difference between the highest and the lowest Emissions(in percent) of High income?
Your response must be concise. 5.14. What is the difference between the highest and the lowest Emissions(in percent) in Small states?
Give a very brief answer. 23.56. What is the difference between the highest and the lowest Emissions(in percent) of Cabo Verde?
Provide a succinct answer. 28.57. What is the difference between the highest and the lowest Emissions(in percent) of Norway?
Make the answer very short. 5.95. 